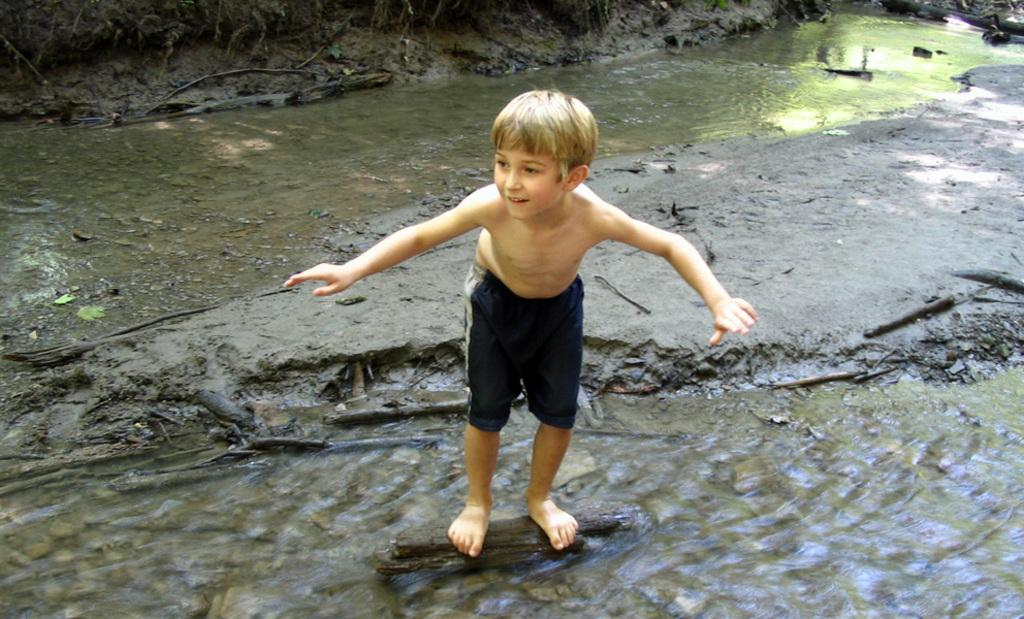Who is the main subject in the image? There is a small boy in the image. What is the boy doing in the image? The boy is standing on a log. What can be seen in the background of the image? There is water at the top and bottom side of the image. What is located in the center of the image? There is a rock in the center of the image. What type of desk is visible in the image? There is no desk present in the image. What does the can want to do in the image? There is no can present in the image, and therefore no desires can be attributed to it. 